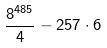Convert formula to latex. <formula><loc_0><loc_0><loc_500><loc_500>\frac { 8 ^ { 4 8 5 } } { 4 } - 2 5 7 \cdot 6</formula> 